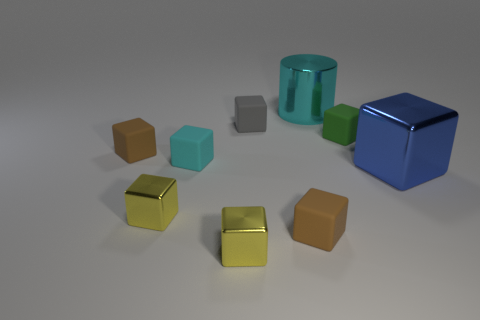The metallic thing that is right of the gray block and in front of the large cyan cylinder is what color?
Give a very brief answer. Blue. There is a rubber cube that is the same color as the large metallic cylinder; what size is it?
Your response must be concise. Small. There is a blue metal thing that is right of the block that is in front of the tiny matte object in front of the blue cube; how big is it?
Provide a short and direct response. Large. What is the gray object made of?
Your response must be concise. Rubber. Does the cylinder have the same material as the cyan thing that is in front of the cyan cylinder?
Offer a very short reply. No. Is there anything else that has the same color as the big metal block?
Ensure brevity in your answer.  No. Is there a tiny green rubber object that is behind the small brown matte block that is in front of the shiny thing right of the cyan shiny object?
Provide a short and direct response. Yes. The large metallic cylinder is what color?
Keep it short and to the point. Cyan. Are there any yellow metallic blocks on the left side of the cyan matte block?
Keep it short and to the point. Yes. There is a green object; does it have the same shape as the tiny metal thing left of the cyan matte block?
Offer a terse response. Yes. 